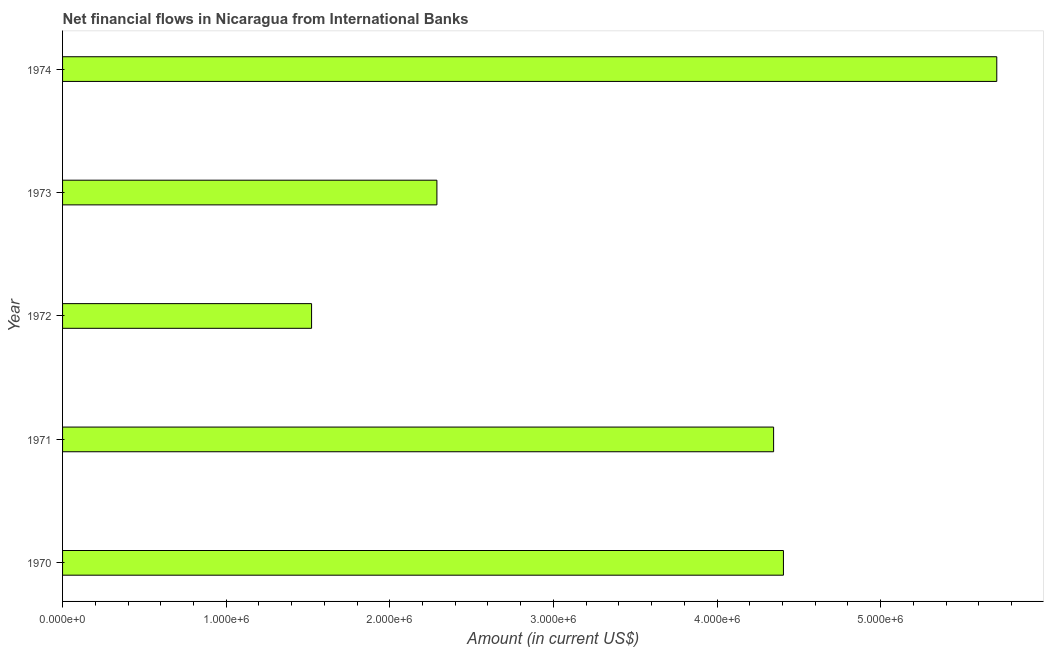Does the graph contain any zero values?
Offer a terse response. No. What is the title of the graph?
Keep it short and to the point. Net financial flows in Nicaragua from International Banks. What is the label or title of the Y-axis?
Your answer should be very brief. Year. What is the net financial flows from ibrd in 1973?
Make the answer very short. 2.29e+06. Across all years, what is the maximum net financial flows from ibrd?
Offer a terse response. 5.71e+06. Across all years, what is the minimum net financial flows from ibrd?
Ensure brevity in your answer.  1.52e+06. In which year was the net financial flows from ibrd maximum?
Offer a very short reply. 1974. In which year was the net financial flows from ibrd minimum?
Provide a succinct answer. 1972. What is the sum of the net financial flows from ibrd?
Provide a succinct answer. 1.83e+07. What is the average net financial flows from ibrd per year?
Ensure brevity in your answer.  3.65e+06. What is the median net financial flows from ibrd?
Offer a very short reply. 4.35e+06. In how many years, is the net financial flows from ibrd greater than 3800000 US$?
Keep it short and to the point. 3. What is the ratio of the net financial flows from ibrd in 1973 to that in 1974?
Provide a short and direct response. 0.4. Is the difference between the net financial flows from ibrd in 1972 and 1973 greater than the difference between any two years?
Provide a short and direct response. No. What is the difference between the highest and the second highest net financial flows from ibrd?
Offer a terse response. 1.30e+06. Is the sum of the net financial flows from ibrd in 1971 and 1974 greater than the maximum net financial flows from ibrd across all years?
Ensure brevity in your answer.  Yes. What is the difference between the highest and the lowest net financial flows from ibrd?
Your answer should be compact. 4.19e+06. In how many years, is the net financial flows from ibrd greater than the average net financial flows from ibrd taken over all years?
Your answer should be very brief. 3. Are the values on the major ticks of X-axis written in scientific E-notation?
Provide a succinct answer. Yes. What is the Amount (in current US$) in 1970?
Your answer should be compact. 4.41e+06. What is the Amount (in current US$) in 1971?
Ensure brevity in your answer.  4.35e+06. What is the Amount (in current US$) in 1972?
Offer a terse response. 1.52e+06. What is the Amount (in current US$) in 1973?
Ensure brevity in your answer.  2.29e+06. What is the Amount (in current US$) of 1974?
Offer a terse response. 5.71e+06. What is the difference between the Amount (in current US$) in 1970 and 1971?
Offer a very short reply. 6.00e+04. What is the difference between the Amount (in current US$) in 1970 and 1972?
Make the answer very short. 2.88e+06. What is the difference between the Amount (in current US$) in 1970 and 1973?
Your answer should be compact. 2.12e+06. What is the difference between the Amount (in current US$) in 1970 and 1974?
Your response must be concise. -1.30e+06. What is the difference between the Amount (in current US$) in 1971 and 1972?
Your answer should be very brief. 2.82e+06. What is the difference between the Amount (in current US$) in 1971 and 1973?
Your response must be concise. 2.06e+06. What is the difference between the Amount (in current US$) in 1971 and 1974?
Offer a very short reply. -1.36e+06. What is the difference between the Amount (in current US$) in 1972 and 1973?
Your answer should be very brief. -7.66e+05. What is the difference between the Amount (in current US$) in 1972 and 1974?
Make the answer very short. -4.19e+06. What is the difference between the Amount (in current US$) in 1973 and 1974?
Your response must be concise. -3.42e+06. What is the ratio of the Amount (in current US$) in 1970 to that in 1971?
Offer a terse response. 1.01. What is the ratio of the Amount (in current US$) in 1970 to that in 1972?
Your answer should be very brief. 2.9. What is the ratio of the Amount (in current US$) in 1970 to that in 1973?
Offer a very short reply. 1.93. What is the ratio of the Amount (in current US$) in 1970 to that in 1974?
Offer a very short reply. 0.77. What is the ratio of the Amount (in current US$) in 1971 to that in 1972?
Give a very brief answer. 2.85. What is the ratio of the Amount (in current US$) in 1971 to that in 1973?
Your response must be concise. 1.9. What is the ratio of the Amount (in current US$) in 1971 to that in 1974?
Make the answer very short. 0.76. What is the ratio of the Amount (in current US$) in 1972 to that in 1973?
Provide a short and direct response. 0.67. What is the ratio of the Amount (in current US$) in 1972 to that in 1974?
Offer a very short reply. 0.27. What is the ratio of the Amount (in current US$) in 1973 to that in 1974?
Keep it short and to the point. 0.4. 